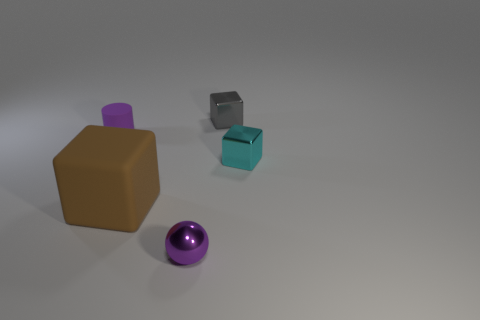Is there anything else that is the same shape as the tiny matte thing?
Your answer should be compact. No. How many large blocks have the same material as the small ball?
Your response must be concise. 0. Is there a tiny purple rubber cylinder that is behind the large matte thing on the left side of the metal thing right of the small gray block?
Your response must be concise. Yes. What is the shape of the small matte thing?
Ensure brevity in your answer.  Cylinder. Is the material of the small object that is to the right of the small gray shiny thing the same as the tiny cube that is behind the tiny purple cylinder?
Offer a very short reply. Yes. How many tiny things have the same color as the big rubber object?
Keep it short and to the point. 0. What is the shape of the metal object that is both behind the brown rubber object and in front of the tiny gray cube?
Your answer should be very brief. Cube. The object that is both in front of the tiny matte cylinder and left of the tiny purple sphere is what color?
Offer a very short reply. Brown. Are there more tiny purple objects that are behind the rubber cylinder than small purple rubber cylinders in front of the small purple metal ball?
Provide a succinct answer. No. There is a matte thing that is left of the large brown matte thing; what is its color?
Ensure brevity in your answer.  Purple. 